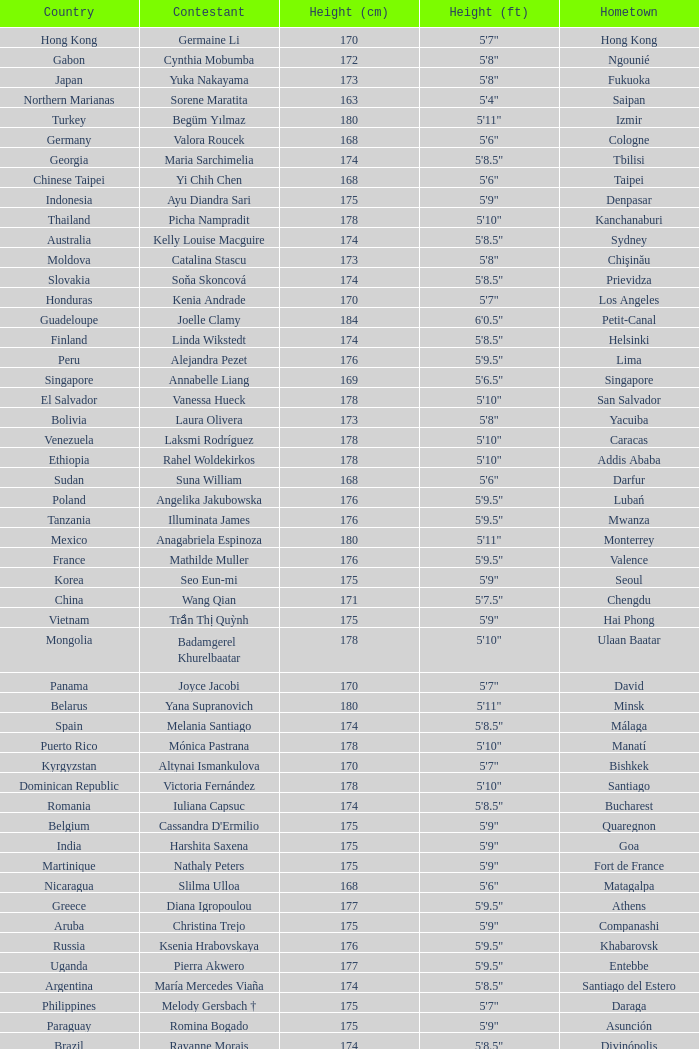What is the hometown of the player from Indonesia? Denpasar. 